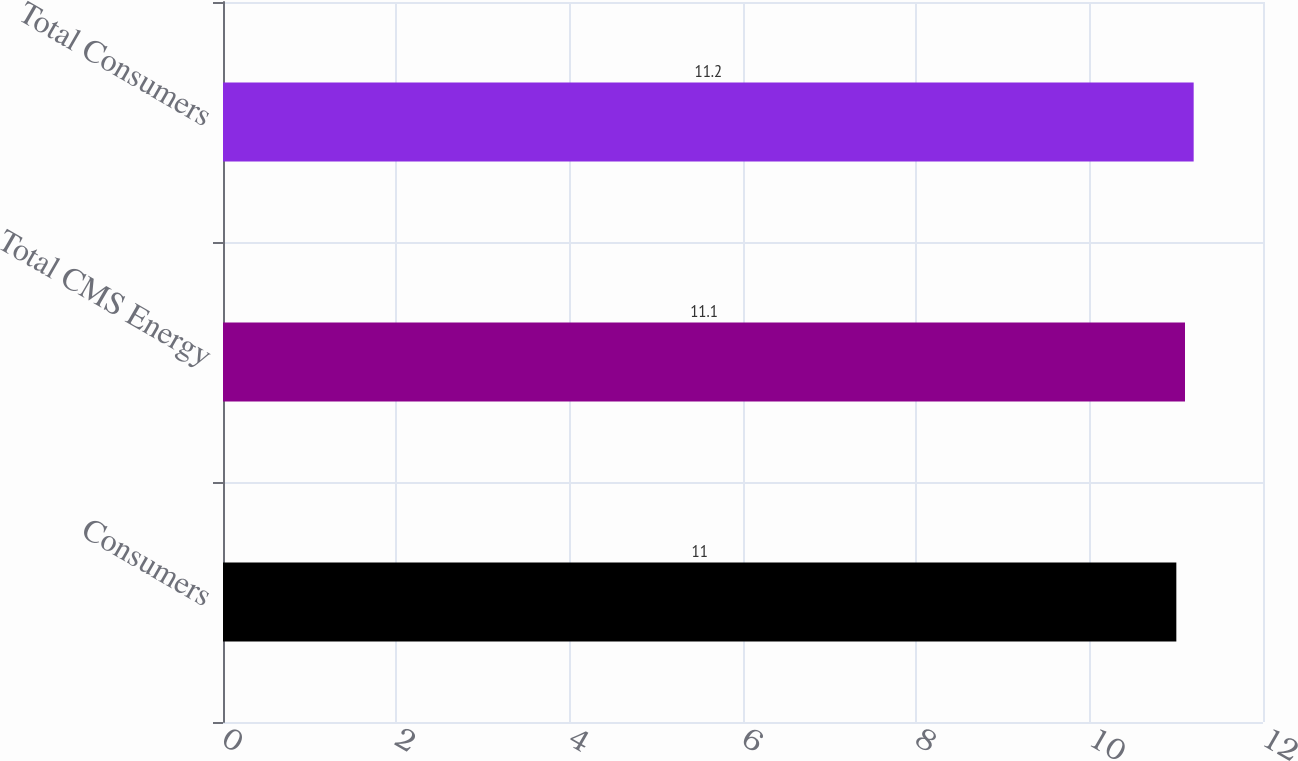Convert chart to OTSL. <chart><loc_0><loc_0><loc_500><loc_500><bar_chart><fcel>Consumers<fcel>Total CMS Energy<fcel>Total Consumers<nl><fcel>11<fcel>11.1<fcel>11.2<nl></chart> 